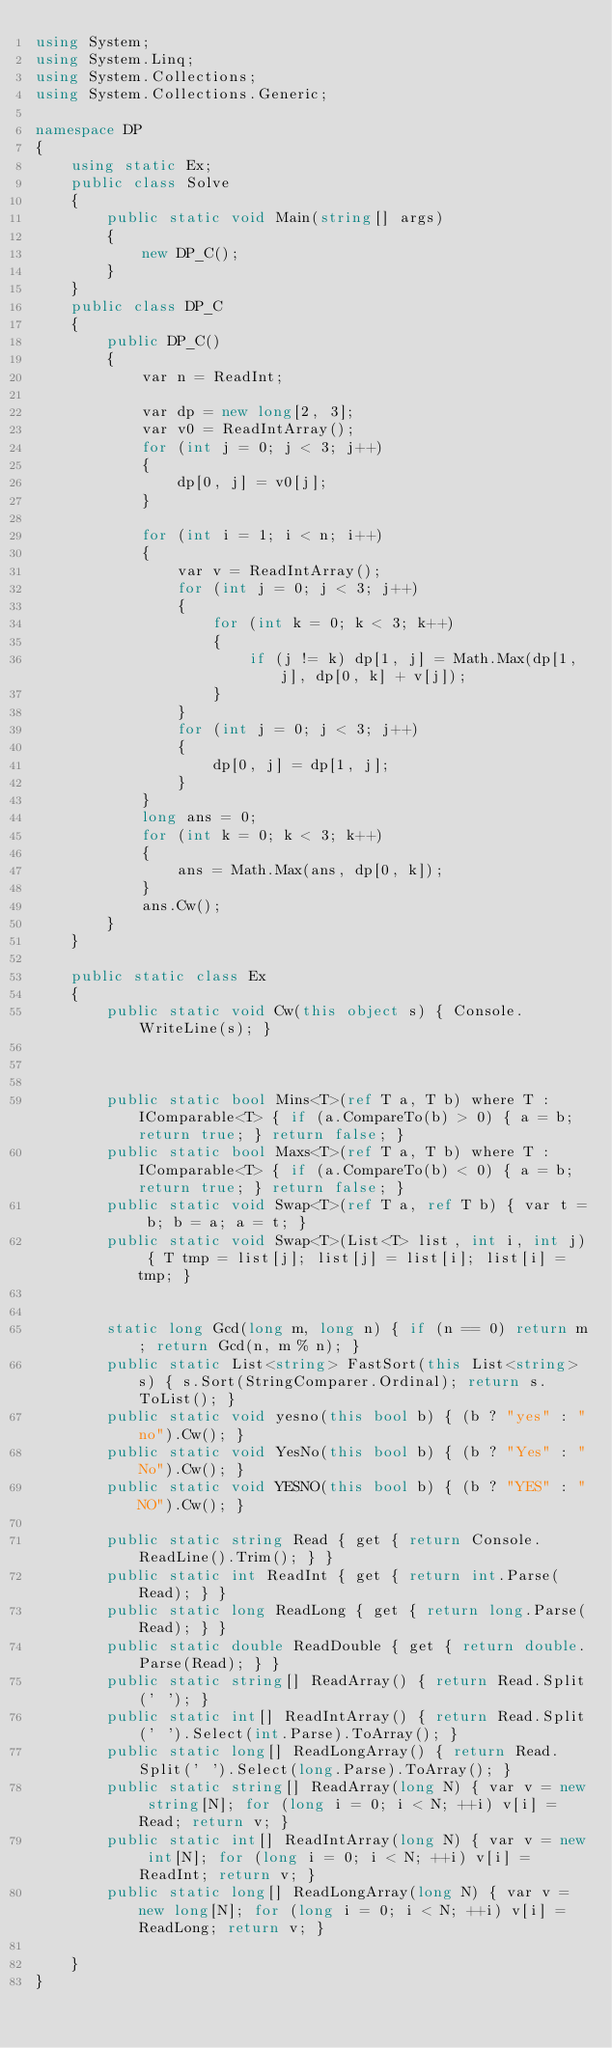<code> <loc_0><loc_0><loc_500><loc_500><_C#_>using System;
using System.Linq;
using System.Collections;
using System.Collections.Generic;

namespace DP
{
    using static Ex;
    public class Solve
    {
        public static void Main(string[] args)
        {
            new DP_C();
        }
    }
    public class DP_C
    {
        public DP_C()
        {
            var n = ReadInt;

            var dp = new long[2, 3];
            var v0 = ReadIntArray();
            for (int j = 0; j < 3; j++)
            {
                dp[0, j] = v0[j];
            }

            for (int i = 1; i < n; i++)
            {
                var v = ReadIntArray();
                for (int j = 0; j < 3; j++)
                {
                    for (int k = 0; k < 3; k++)
                    {
                        if (j != k) dp[1, j] = Math.Max(dp[1, j], dp[0, k] + v[j]);
                    }
                }
                for (int j = 0; j < 3; j++)
                {
                    dp[0, j] = dp[1, j];
                }
            }
            long ans = 0;
            for (int k = 0; k < 3; k++)
            {
                ans = Math.Max(ans, dp[0, k]);
            }
            ans.Cw();
        }
    }

    public static class Ex
    {
        public static void Cw(this object s) { Console.WriteLine(s); }



        public static bool Mins<T>(ref T a, T b) where T : IComparable<T> { if (a.CompareTo(b) > 0) { a = b; return true; } return false; }
        public static bool Maxs<T>(ref T a, T b) where T : IComparable<T> { if (a.CompareTo(b) < 0) { a = b; return true; } return false; }
        public static void Swap<T>(ref T a, ref T b) { var t = b; b = a; a = t; }
        public static void Swap<T>(List<T> list, int i, int j) { T tmp = list[j]; list[j] = list[i]; list[i] = tmp; }


        static long Gcd(long m, long n) { if (n == 0) return m; return Gcd(n, m % n); }
        public static List<string> FastSort(this List<string> s) { s.Sort(StringComparer.Ordinal); return s.ToList(); }
        public static void yesno(this bool b) { (b ? "yes" : "no").Cw(); }
        public static void YesNo(this bool b) { (b ? "Yes" : "No").Cw(); }
        public static void YESNO(this bool b) { (b ? "YES" : "NO").Cw(); }

        public static string Read { get { return Console.ReadLine().Trim(); } }
        public static int ReadInt { get { return int.Parse(Read); } }
        public static long ReadLong { get { return long.Parse(Read); } }
        public static double ReadDouble { get { return double.Parse(Read); } }
        public static string[] ReadArray() { return Read.Split(' '); }
        public static int[] ReadIntArray() { return Read.Split(' ').Select(int.Parse).ToArray(); }
        public static long[] ReadLongArray() { return Read.Split(' ').Select(long.Parse).ToArray(); }
        public static string[] ReadArray(long N) { var v = new string[N]; for (long i = 0; i < N; ++i) v[i] = Read; return v; }
        public static int[] ReadIntArray(long N) { var v = new int[N]; for (long i = 0; i < N; ++i) v[i] = ReadInt; return v; }
        public static long[] ReadLongArray(long N) { var v = new long[N]; for (long i = 0; i < N; ++i) v[i] = ReadLong; return v; }

    }
}</code> 